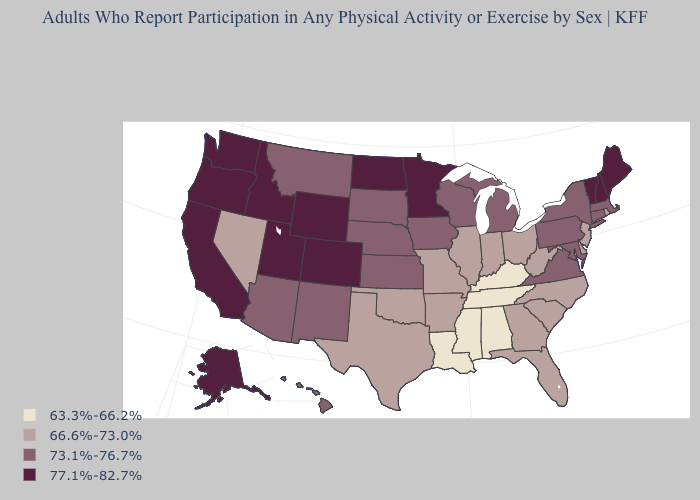What is the highest value in the Northeast ?
Answer briefly. 77.1%-82.7%. Which states have the highest value in the USA?
Short answer required. Alaska, California, Colorado, Idaho, Maine, Minnesota, New Hampshire, North Dakota, Oregon, Utah, Vermont, Washington, Wyoming. Does Hawaii have the highest value in the West?
Keep it brief. No. Which states have the lowest value in the USA?
Give a very brief answer. Alabama, Kentucky, Louisiana, Mississippi, Tennessee. Among the states that border Indiana , which have the lowest value?
Give a very brief answer. Kentucky. Does Vermont have the lowest value in the Northeast?
Concise answer only. No. Name the states that have a value in the range 63.3%-66.2%?
Answer briefly. Alabama, Kentucky, Louisiana, Mississippi, Tennessee. What is the value of Alaska?
Give a very brief answer. 77.1%-82.7%. What is the value of New Hampshire?
Write a very short answer. 77.1%-82.7%. How many symbols are there in the legend?
Answer briefly. 4. Which states hav the highest value in the Northeast?
Concise answer only. Maine, New Hampshire, Vermont. Is the legend a continuous bar?
Answer briefly. No. What is the lowest value in the South?
Short answer required. 63.3%-66.2%. What is the value of Maine?
Short answer required. 77.1%-82.7%. Name the states that have a value in the range 77.1%-82.7%?
Be succinct. Alaska, California, Colorado, Idaho, Maine, Minnesota, New Hampshire, North Dakota, Oregon, Utah, Vermont, Washington, Wyoming. 